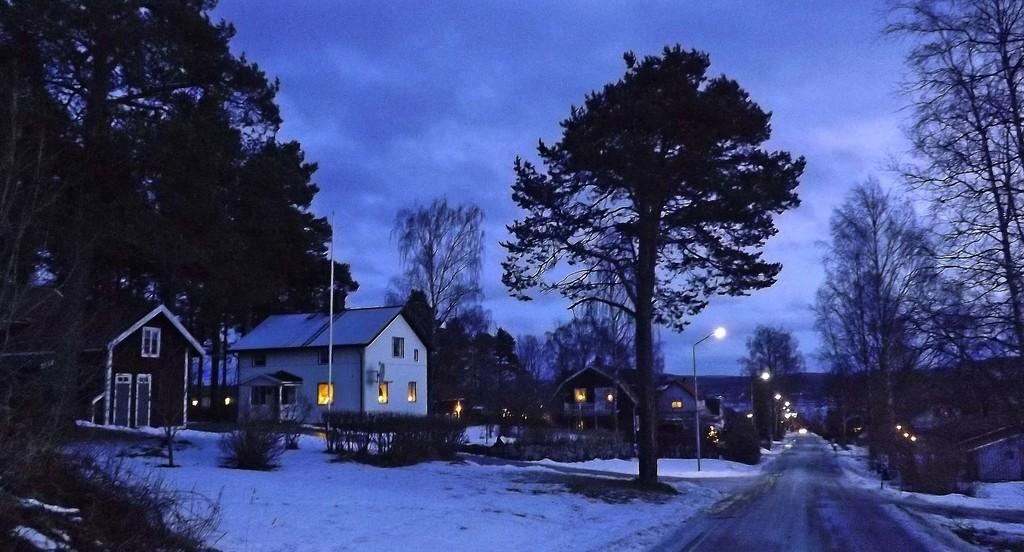What type of scenery is depicted in the image? The image contains a beautiful view of houses and trees. Where is the road located in the image? The road is in the front bottom side of the image. How is the road positioned in relation to the other elements in the image? The road is in the middle of the image. What is the ground covered with in the image? There is snow on the ground in the image. What can be seen at the top of the image? The sky is visible at the top of the image. What crime is being committed in the image? There is no crime being committed in the image; it depicts a peaceful scene of houses, trees, and a road with snow on the ground. What is the price of the houses in the image? The image does not provide any information about the price of the houses; it only shows their appearance. 